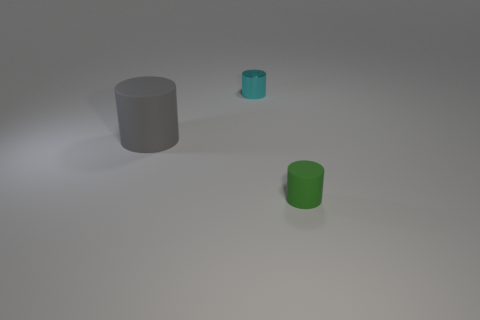There is a green object that is to the right of the cyan metallic object; what shape is it? The green object to the right of the cyan object is cylindrical in shape, resembling a classic can or barrel form with a circular base and uniform cross-section throughout its height. 